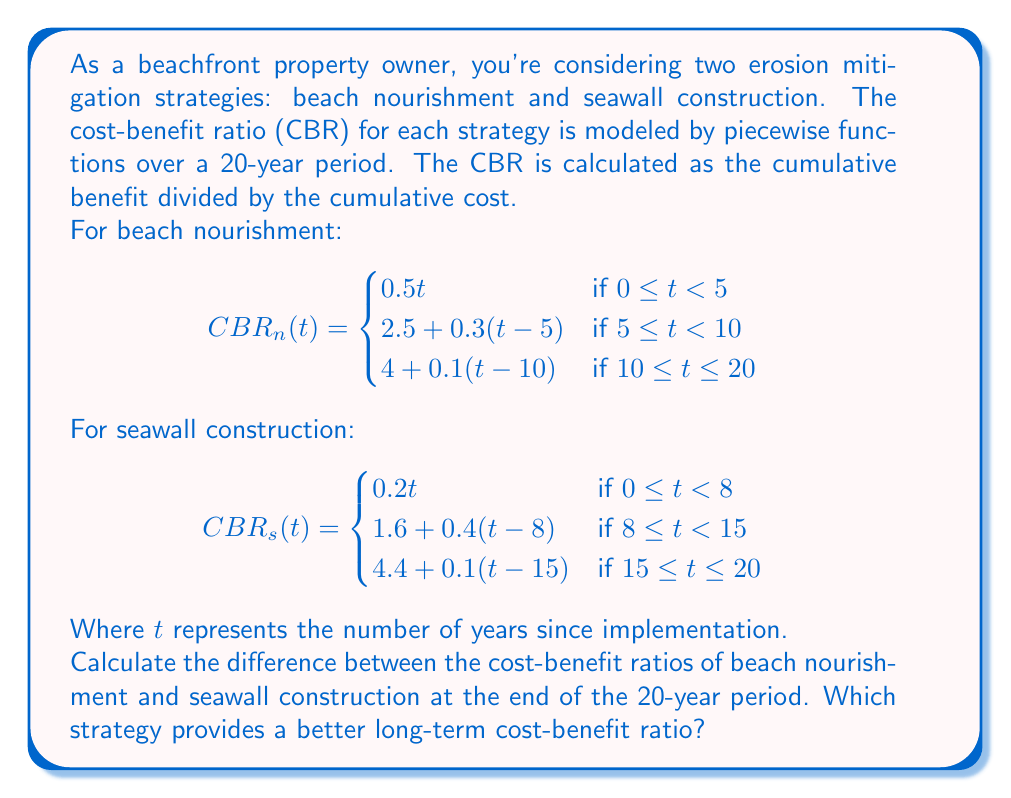Show me your answer to this math problem. To solve this problem, we need to evaluate both piecewise functions at $t = 20$ and then find the difference.

1. Evaluate $CBR_n(20)$ (beach nourishment):
   Since $20 > 10$, we use the third piece of the function:
   $$CBR_n(20) = 4 + 0.1(20-10) = 4 + 0.1(10) = 4 + 1 = 5$$

2. Evaluate $CBR_s(20)$ (seawall construction):
   Since $20 > 15$, we use the third piece of the function:
   $$CBR_s(20) = 4.4 + 0.1(20-15) = 4.4 + 0.1(5) = 4.4 + 0.5 = 4.9$$

3. Calculate the difference:
   $$CBR_n(20) - CBR_s(20) = 5 - 4.9 = 0.1$$

The positive difference indicates that beach nourishment has a higher cost-benefit ratio at the end of the 20-year period.

To determine which strategy provides a better long-term cost-benefit ratio, we compare the final values:
- Beach nourishment: $CBR_n(20) = 5$
- Seawall construction: $CBR_s(20) = 4.9$

Since $5 > 4.9$, beach nourishment provides a better long-term cost-benefit ratio.
Answer: The difference between the cost-benefit ratios of beach nourishment and seawall construction at the end of the 20-year period is 0.1. Beach nourishment provides a better long-term cost-benefit ratio with a value of 5 compared to seawall construction's 4.9. 